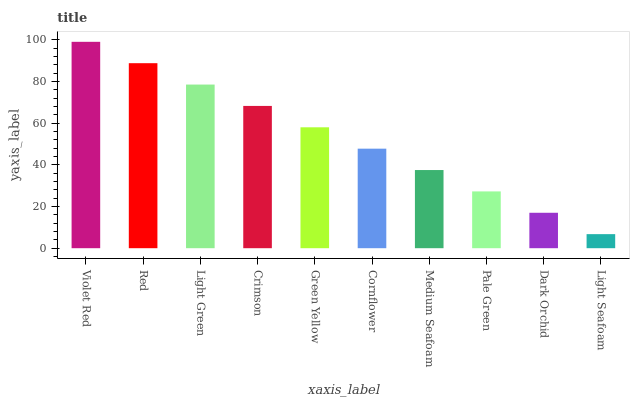Is Light Seafoam the minimum?
Answer yes or no. Yes. Is Violet Red the maximum?
Answer yes or no. Yes. Is Red the minimum?
Answer yes or no. No. Is Red the maximum?
Answer yes or no. No. Is Violet Red greater than Red?
Answer yes or no. Yes. Is Red less than Violet Red?
Answer yes or no. Yes. Is Red greater than Violet Red?
Answer yes or no. No. Is Violet Red less than Red?
Answer yes or no. No. Is Green Yellow the high median?
Answer yes or no. Yes. Is Cornflower the low median?
Answer yes or no. Yes. Is Violet Red the high median?
Answer yes or no. No. Is Light Green the low median?
Answer yes or no. No. 